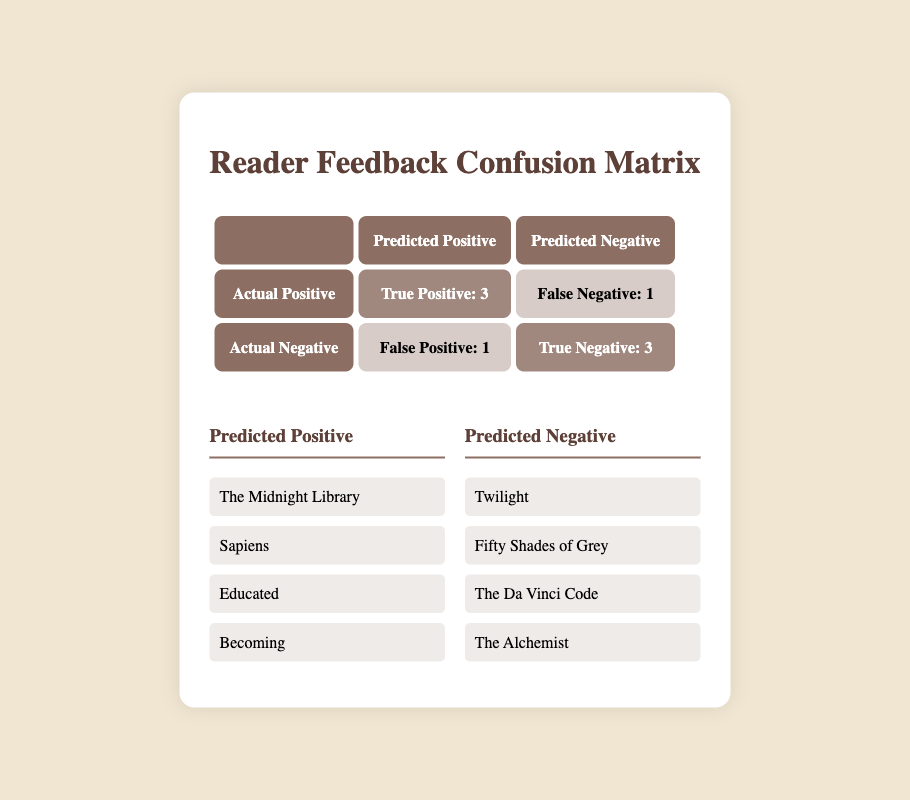What is the True Positive count? The True Positive count is listed in the confusion matrix. It shows the number of positive predictions that were correct, which is specified as "True Positive: 3".
Answer: 3 How many True Negatives are there? The True Negative count is indicated in the matrix. It represents the number of negative predictions that were correct, which is specified as "True Negative: 3".
Answer: 3 What is the total number of predictions made? To find the total number of predictions, we sum all categories in the confusion matrix: True Positive (3) + False Positive (1) + True Negative (3) + False Negative (1) = 8.
Answer: 8 Is the False Negative count greater than the False Positive count? The False Negative count is given as 1 and the False Positive count is also given as 1. Since they are equal, the statement is false.
Answer: No What is the difference between True Positives and False Negatives? The True Positive count is 3, and the False Negative count is 1. The difference is calculated as 3 - 1 = 2.
Answer: 2 If you consider only the negative predictions, what percentage is True Negatives? The True Negatives are 3 and the False Positives are 1. The total negative predictions is 3 + 1 = 4. The percentage of True Negatives is calculated as (3/4) * 100 = 75%.
Answer: 75% What is the implication of having more True Positives than False Negatives? Having more True Positives (3) than False Negatives (1) indicates that the model is effectively identifying positive feedback. This suggests that the recommendations are generally well-received by readers.
Answer: Positive implication What can you infer from the total number of Negative predictions compared to Positive predictions? The total number of Negative predictions is 4 (3 True Negatives + 1 False Positive), while the total number of Positive predictions is 4 (3 True Positives + 1 False Negative). They are equal, indicating a balanced performance in predicting negatives and positives.
Answer: They are equal 